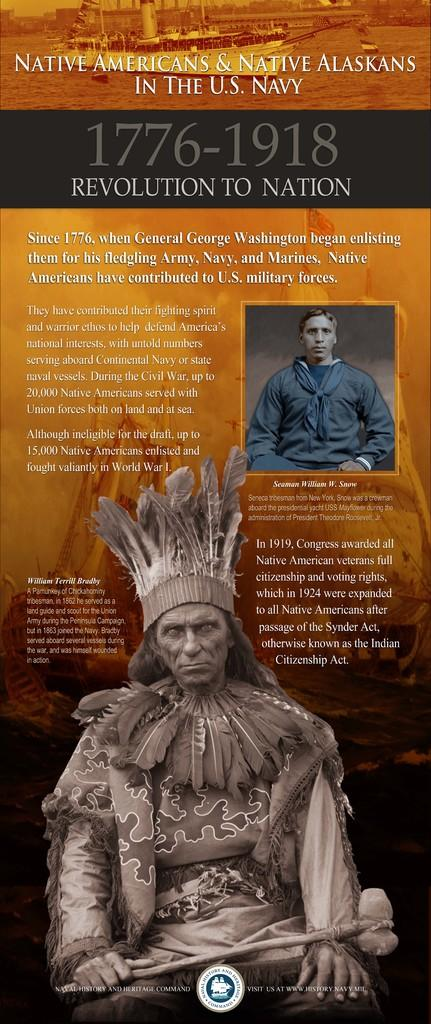What is the person in the foreground wearing in the image? The person in the foreground is wearing a brown-colored costume in the image. Can you describe the person in the background? There is another person in the background wearing a blue-colored dress. What else can be seen in the image besides the people? There is text or writing visible in the image. Reasoning: Let'g: Let's think step by step in order to produce the conversation. We start by identifying the main subjects in the image, which are the two people. Then, we describe their clothing to provide more detail about their appearance. Finally, we mention the presence of text or writing in the image to acknowledge another element present. Absurd Question/Answer: What type of goldfish is swimming in the person's thought bubble in the image? There is no goldfish or thought bubble present in the image. How does the person adjust their costume during the event in the image? There is no information about an event or the person adjusting their costume in the image. What is the person holding in the image? The person is holding a book in the image. Can you describe the book? The book has a red cover. Where is the person sitting in the image? The person is sitting on a chair. What is on the table in front of the person? The table has a lamp on it. Reasoning: Let's think step by step in order to produce the conversation. We start by identifying the main subject in the image, which is the person holding a book. Then, we describe the book's appearance, including its red cover. Next, we mention the person's location, which is sitting on a chair. Finally, we describe the table and its contents, which include a lamp. Each question is designed to elicit a specific detail about the image that is known from the provided facts. Absurd Question/Answer: 